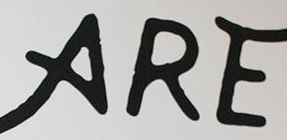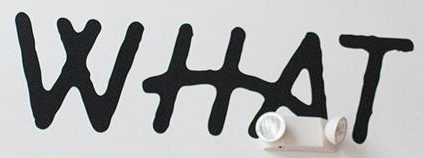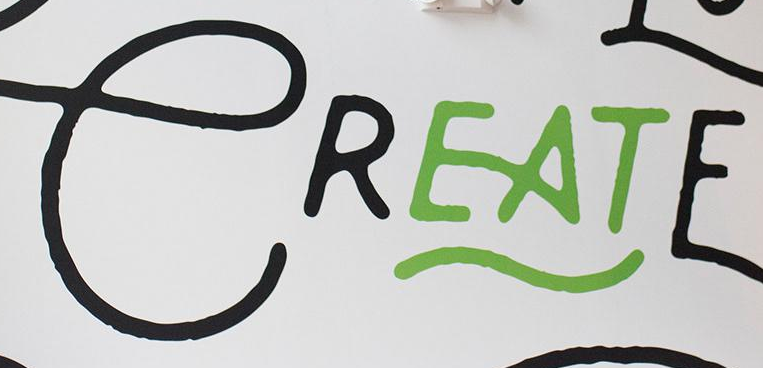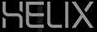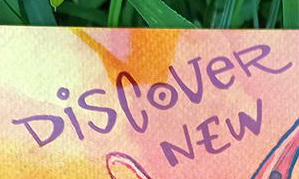Transcribe the words shown in these images in order, separated by a semicolon. ARE; WHAT; CREATE; HELIX; DiSCoVeR 